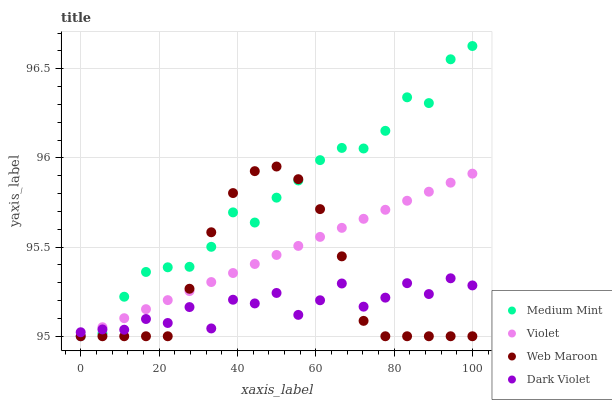Does Dark Violet have the minimum area under the curve?
Answer yes or no. Yes. Does Medium Mint have the maximum area under the curve?
Answer yes or no. Yes. Does Web Maroon have the minimum area under the curve?
Answer yes or no. No. Does Web Maroon have the maximum area under the curve?
Answer yes or no. No. Is Violet the smoothest?
Answer yes or no. Yes. Is Dark Violet the roughest?
Answer yes or no. Yes. Is Web Maroon the smoothest?
Answer yes or no. No. Is Web Maroon the roughest?
Answer yes or no. No. Does Medium Mint have the lowest value?
Answer yes or no. Yes. Does Dark Violet have the lowest value?
Answer yes or no. No. Does Medium Mint have the highest value?
Answer yes or no. Yes. Does Web Maroon have the highest value?
Answer yes or no. No. Does Dark Violet intersect Web Maroon?
Answer yes or no. Yes. Is Dark Violet less than Web Maroon?
Answer yes or no. No. Is Dark Violet greater than Web Maroon?
Answer yes or no. No. 